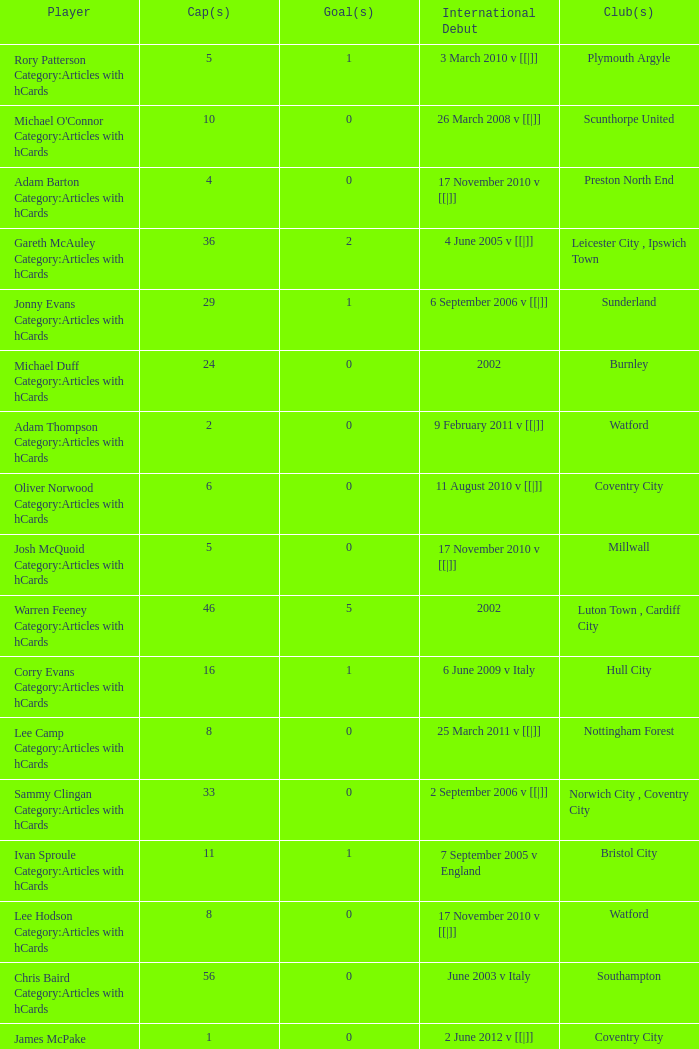How many players had 8 goals? 1.0. 